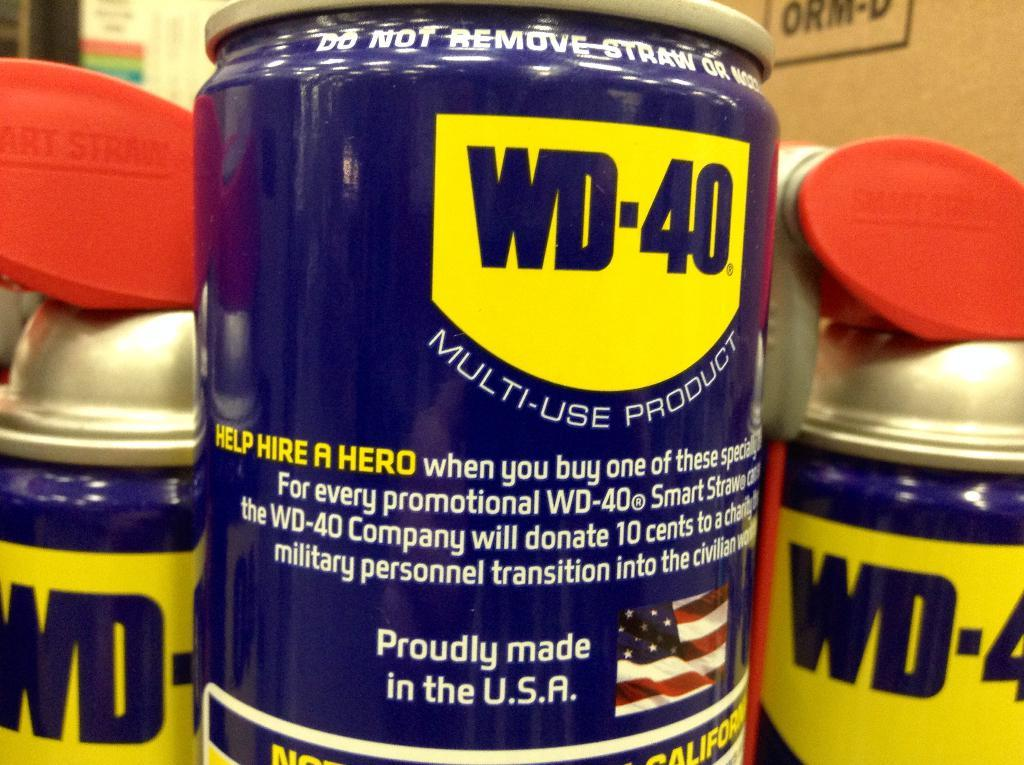<image>
Describe the image concisely. A mission statement for the benefits of the purchase of a can of WD-40. 